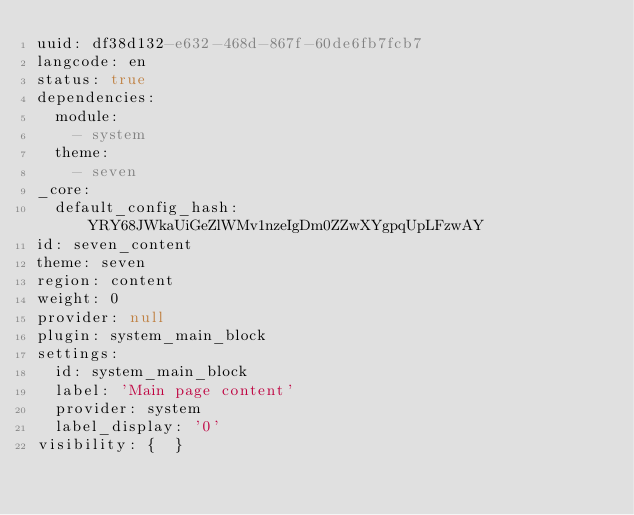<code> <loc_0><loc_0><loc_500><loc_500><_YAML_>uuid: df38d132-e632-468d-867f-60de6fb7fcb7
langcode: en
status: true
dependencies:
  module:
    - system
  theme:
    - seven
_core:
  default_config_hash: YRY68JWkaUiGeZlWMv1nzeIgDm0ZZwXYgpqUpLFzwAY
id: seven_content
theme: seven
region: content
weight: 0
provider: null
plugin: system_main_block
settings:
  id: system_main_block
  label: 'Main page content'
  provider: system
  label_display: '0'
visibility: {  }
</code> 